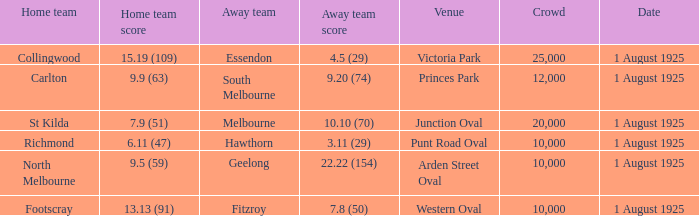What was the number of spectators when the away team scored 4.5 (29) in the match? 1.0. 